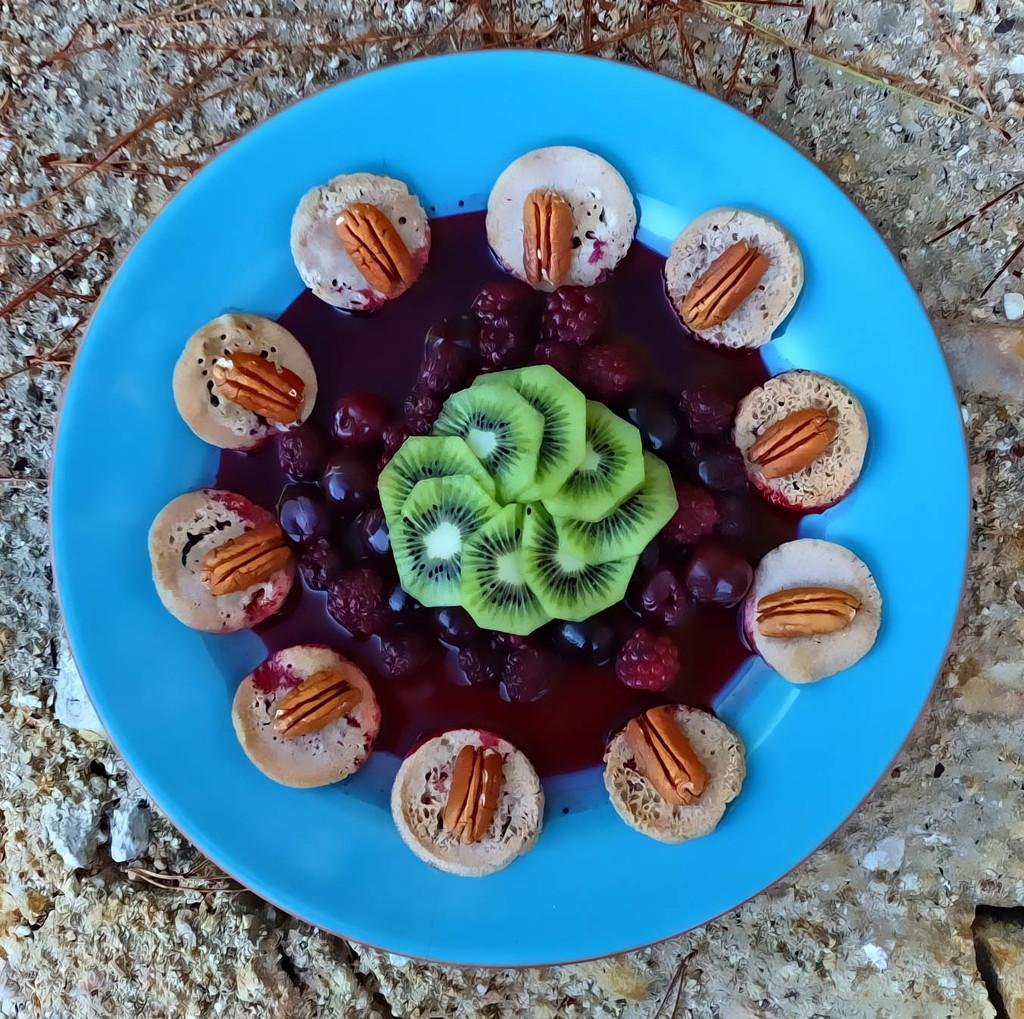What is on the plate that is visible in the image? The plate contains fruits, cookies, and food items. Where might the plate be located in the image? The plate may be on the floor. Can you tell if the image was taken during the day or night? The image was likely taken during the day. What type of lumber is being used by the minister in the image? There is no minister or lumber present in the image. 